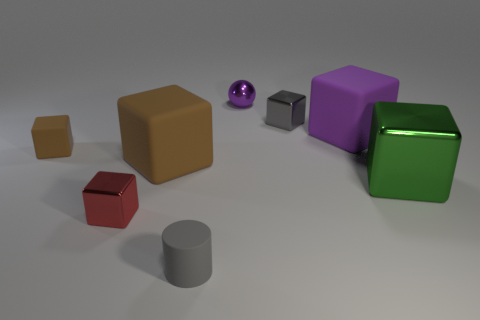Do the large brown thing and the big green thing have the same material?
Ensure brevity in your answer.  No. There is a gray thing that is behind the gray matte thing; how many small shiny cubes are in front of it?
Ensure brevity in your answer.  1. Are there any cyan things that have the same shape as the red thing?
Your answer should be very brief. No. There is a small object on the right side of the small sphere; is its shape the same as the brown thing that is left of the small red block?
Keep it short and to the point. Yes. What shape is the small object that is both left of the gray cylinder and right of the small brown rubber thing?
Offer a terse response. Cube. Are there any yellow matte objects of the same size as the red object?
Your answer should be very brief. No. Is the color of the large metallic object the same as the rubber thing in front of the large green object?
Your response must be concise. No. What material is the ball?
Offer a very short reply. Metal. What color is the tiny metal thing in front of the large green object?
Make the answer very short. Red. How many large things are the same color as the sphere?
Provide a succinct answer. 1. 